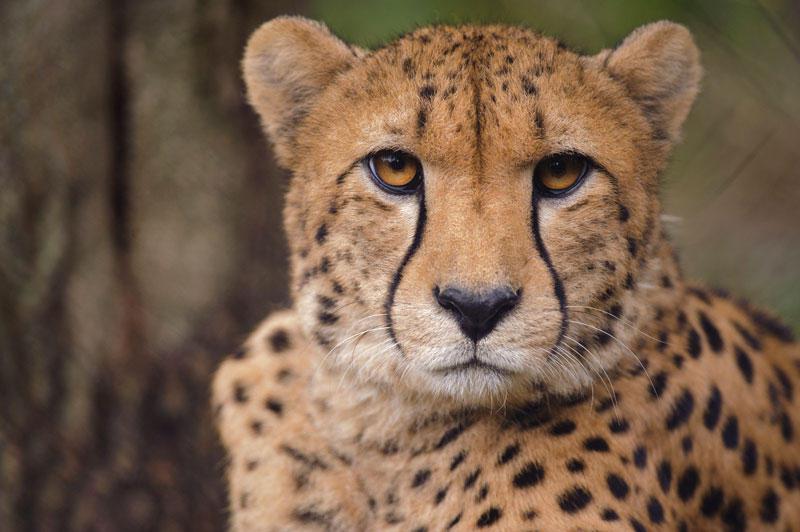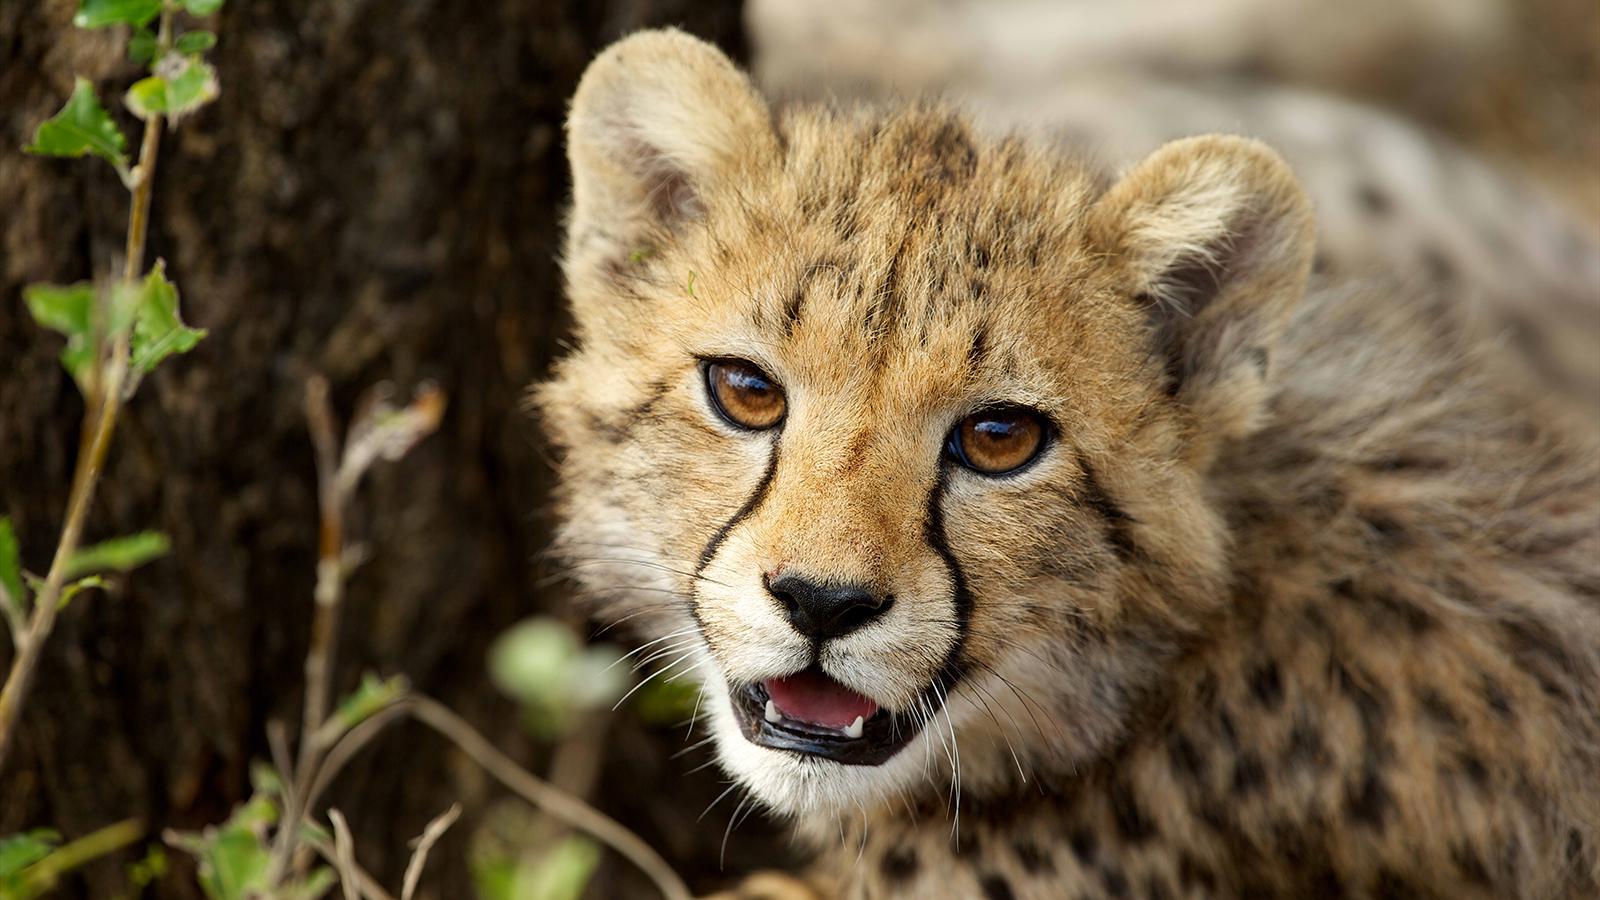The first image is the image on the left, the second image is the image on the right. Evaluate the accuracy of this statement regarding the images: "There are two cats in the image on the right.". Is it true? Answer yes or no. No. 